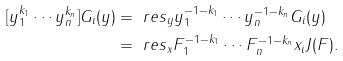<formula> <loc_0><loc_0><loc_500><loc_500>[ y _ { 1 } ^ { k _ { 1 } } \cdots y _ { n } ^ { k _ { n } } ] G _ { i } ( y ) & = \ r e s _ { y } y _ { 1 } ^ { - 1 - k _ { 1 } } \cdots y _ { n } ^ { - 1 - k _ { n } } G _ { i } ( y ) \\ & = \ r e s _ { x } F _ { 1 } ^ { - 1 - k _ { 1 } } \cdots F _ { n } ^ { - 1 - k _ { n } } x _ { i } J ( F ) .</formula> 